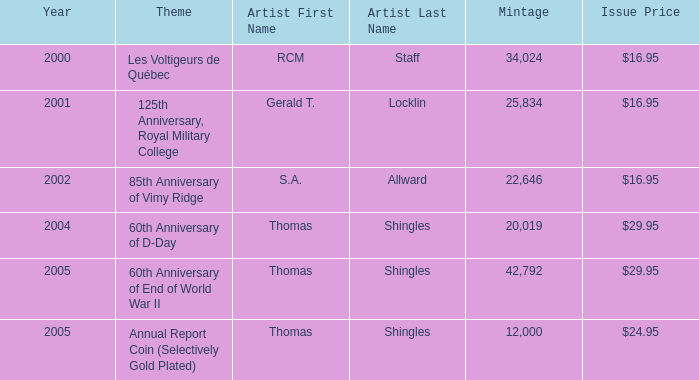What was the total mintage for years after 2002 that had a 85th Anniversary of Vimy Ridge theme? 0.0. 